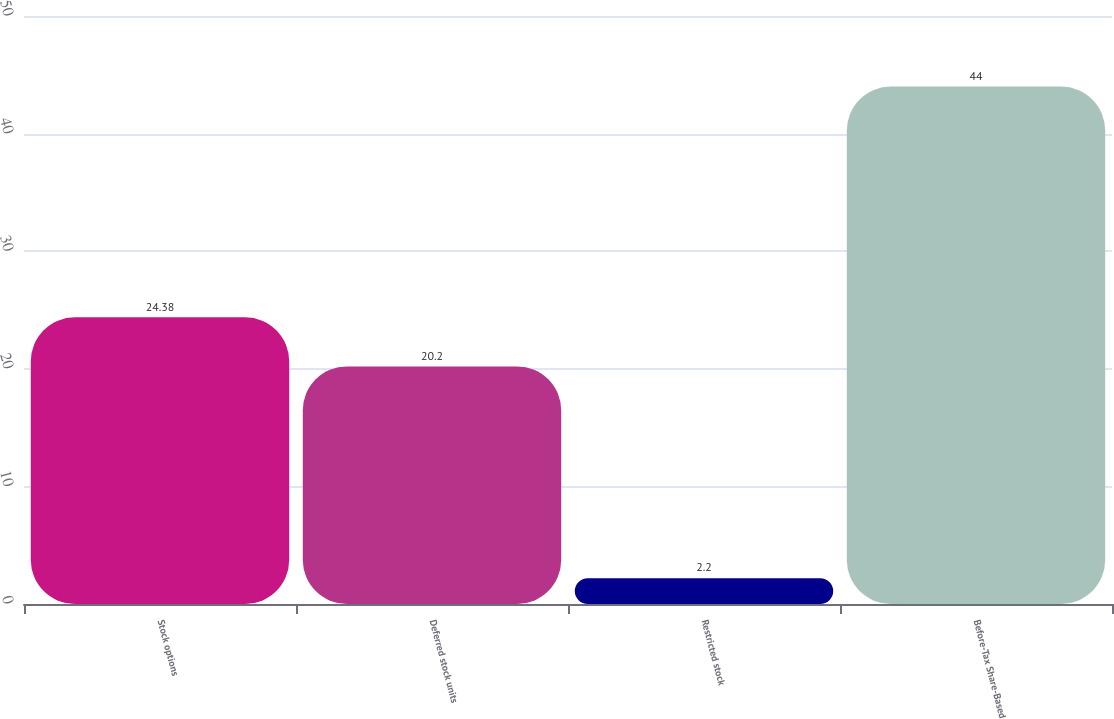Convert chart. <chart><loc_0><loc_0><loc_500><loc_500><bar_chart><fcel>Stock options<fcel>Deferred stock units<fcel>Restricted stock<fcel>Before-Tax Share-Based<nl><fcel>24.38<fcel>20.2<fcel>2.2<fcel>44<nl></chart> 